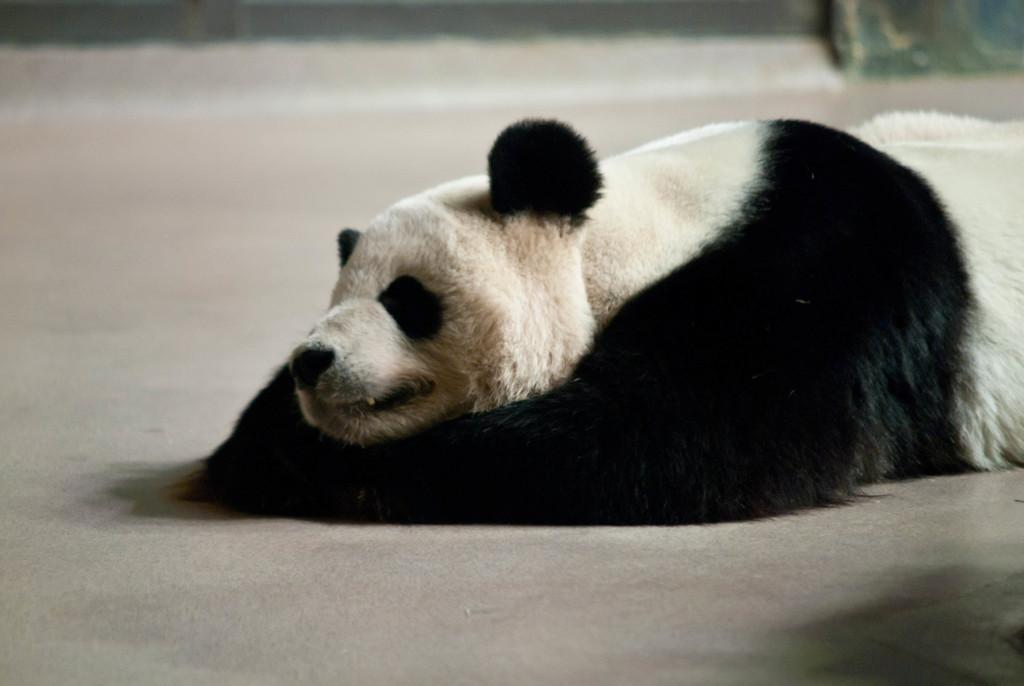What type of living organism can be seen in the image? There is an animal in the image. Can you describe the position of the animal in the image? The animal is lying on the land. What type of linen is the animal using to cover itself in the image? There is no linen present in the image, and the animal is not using any fabric to cover itself. How many horns can be seen on the animal in the image? There is no indication of any horns on the animal in the image. 